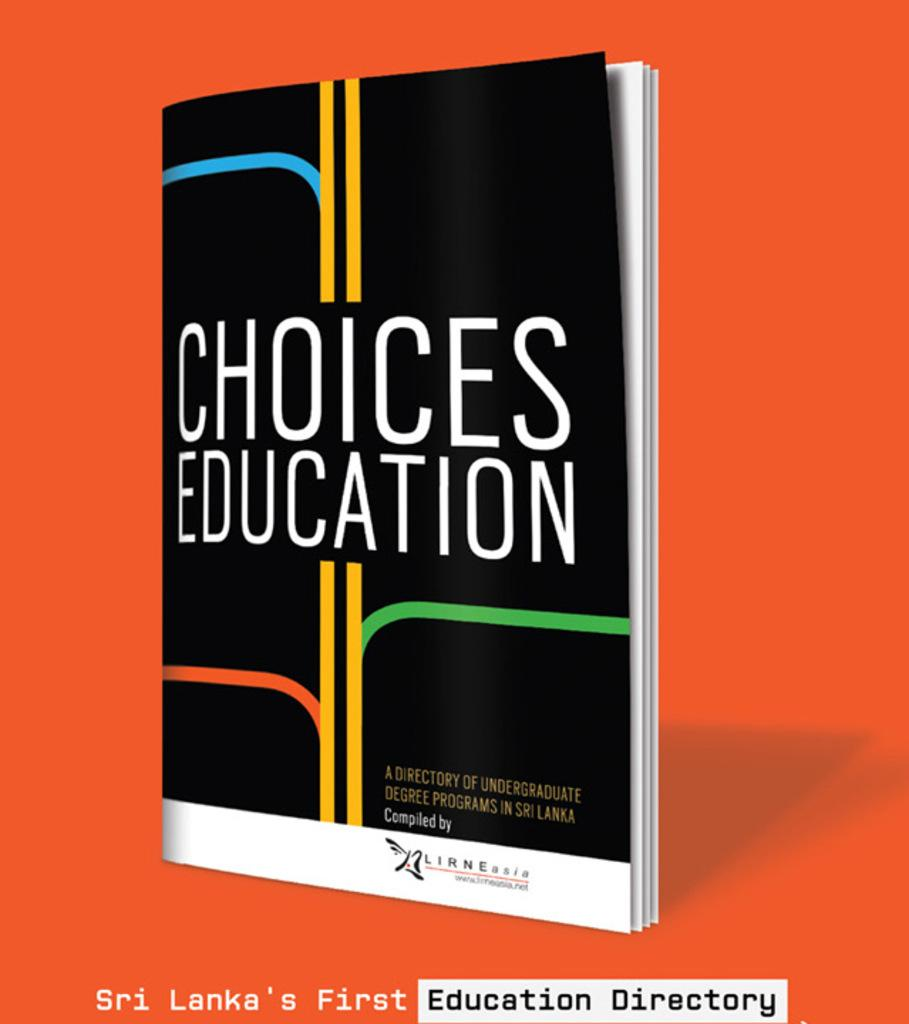<image>
Offer a succinct explanation of the picture presented. Book cover for Choices Education showing yellow, blue, orange, and green lines. 